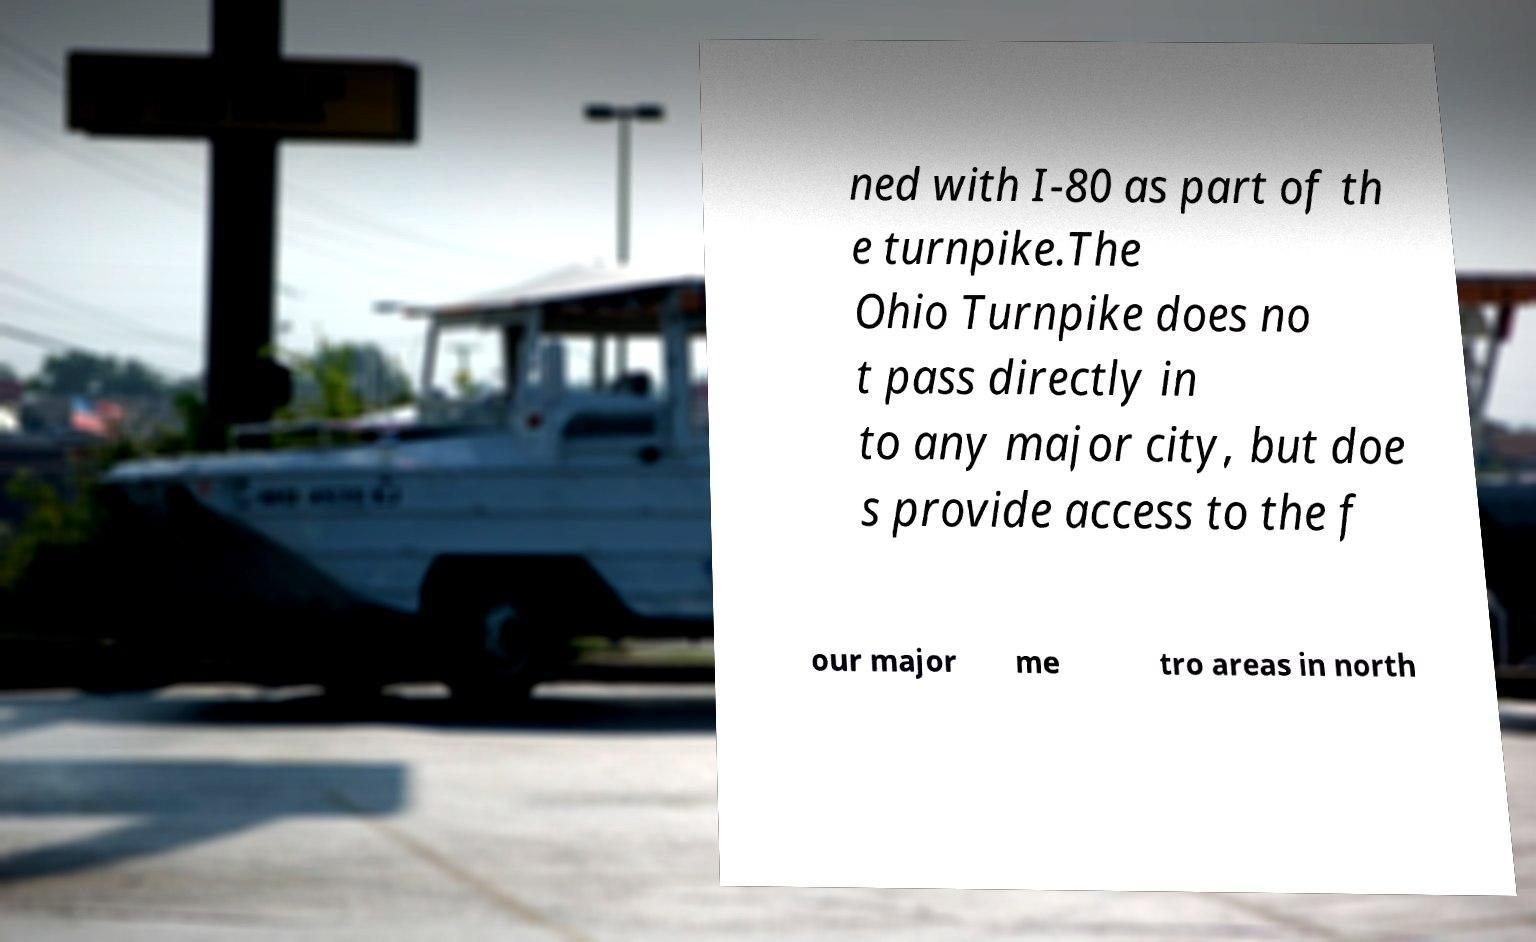Please identify and transcribe the text found in this image. ned with I-80 as part of th e turnpike.The Ohio Turnpike does no t pass directly in to any major city, but doe s provide access to the f our major me tro areas in north 